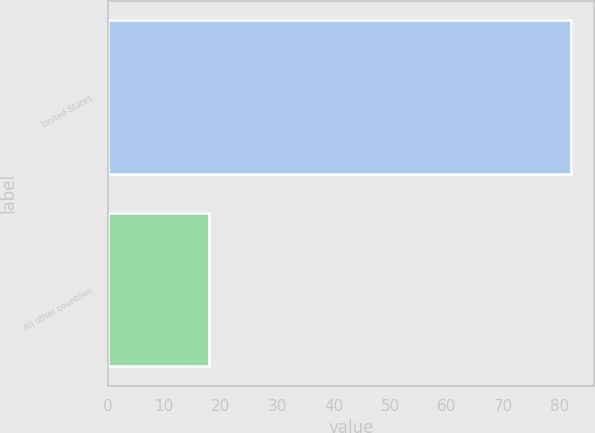Convert chart to OTSL. <chart><loc_0><loc_0><loc_500><loc_500><bar_chart><fcel>United States<fcel>All other countries<nl><fcel>82<fcel>18<nl></chart> 